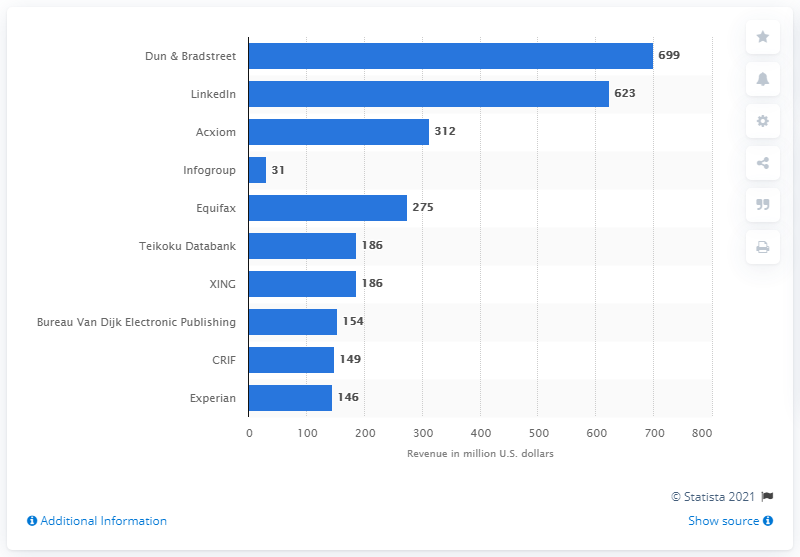Highlight a few significant elements in this photo. Dun & Bradstreet's revenue in the measured period was $699 million. In 2016, Dun & Bradstreet was ranked as the top B2B marketing technology company. 